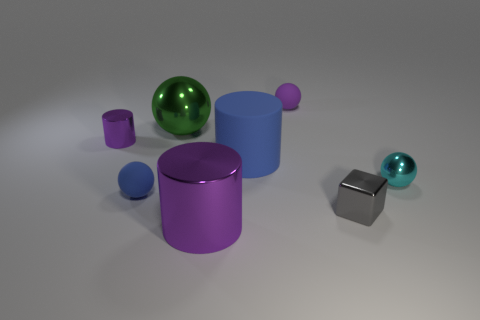Add 1 purple metal balls. How many objects exist? 9 Subtract all blocks. How many objects are left? 7 Subtract 0 red cubes. How many objects are left? 8 Subtract all tiny purple metal things. Subtract all purple shiny cylinders. How many objects are left? 5 Add 7 green metallic spheres. How many green metallic spheres are left? 8 Add 6 large brown metallic things. How many large brown metallic things exist? 6 